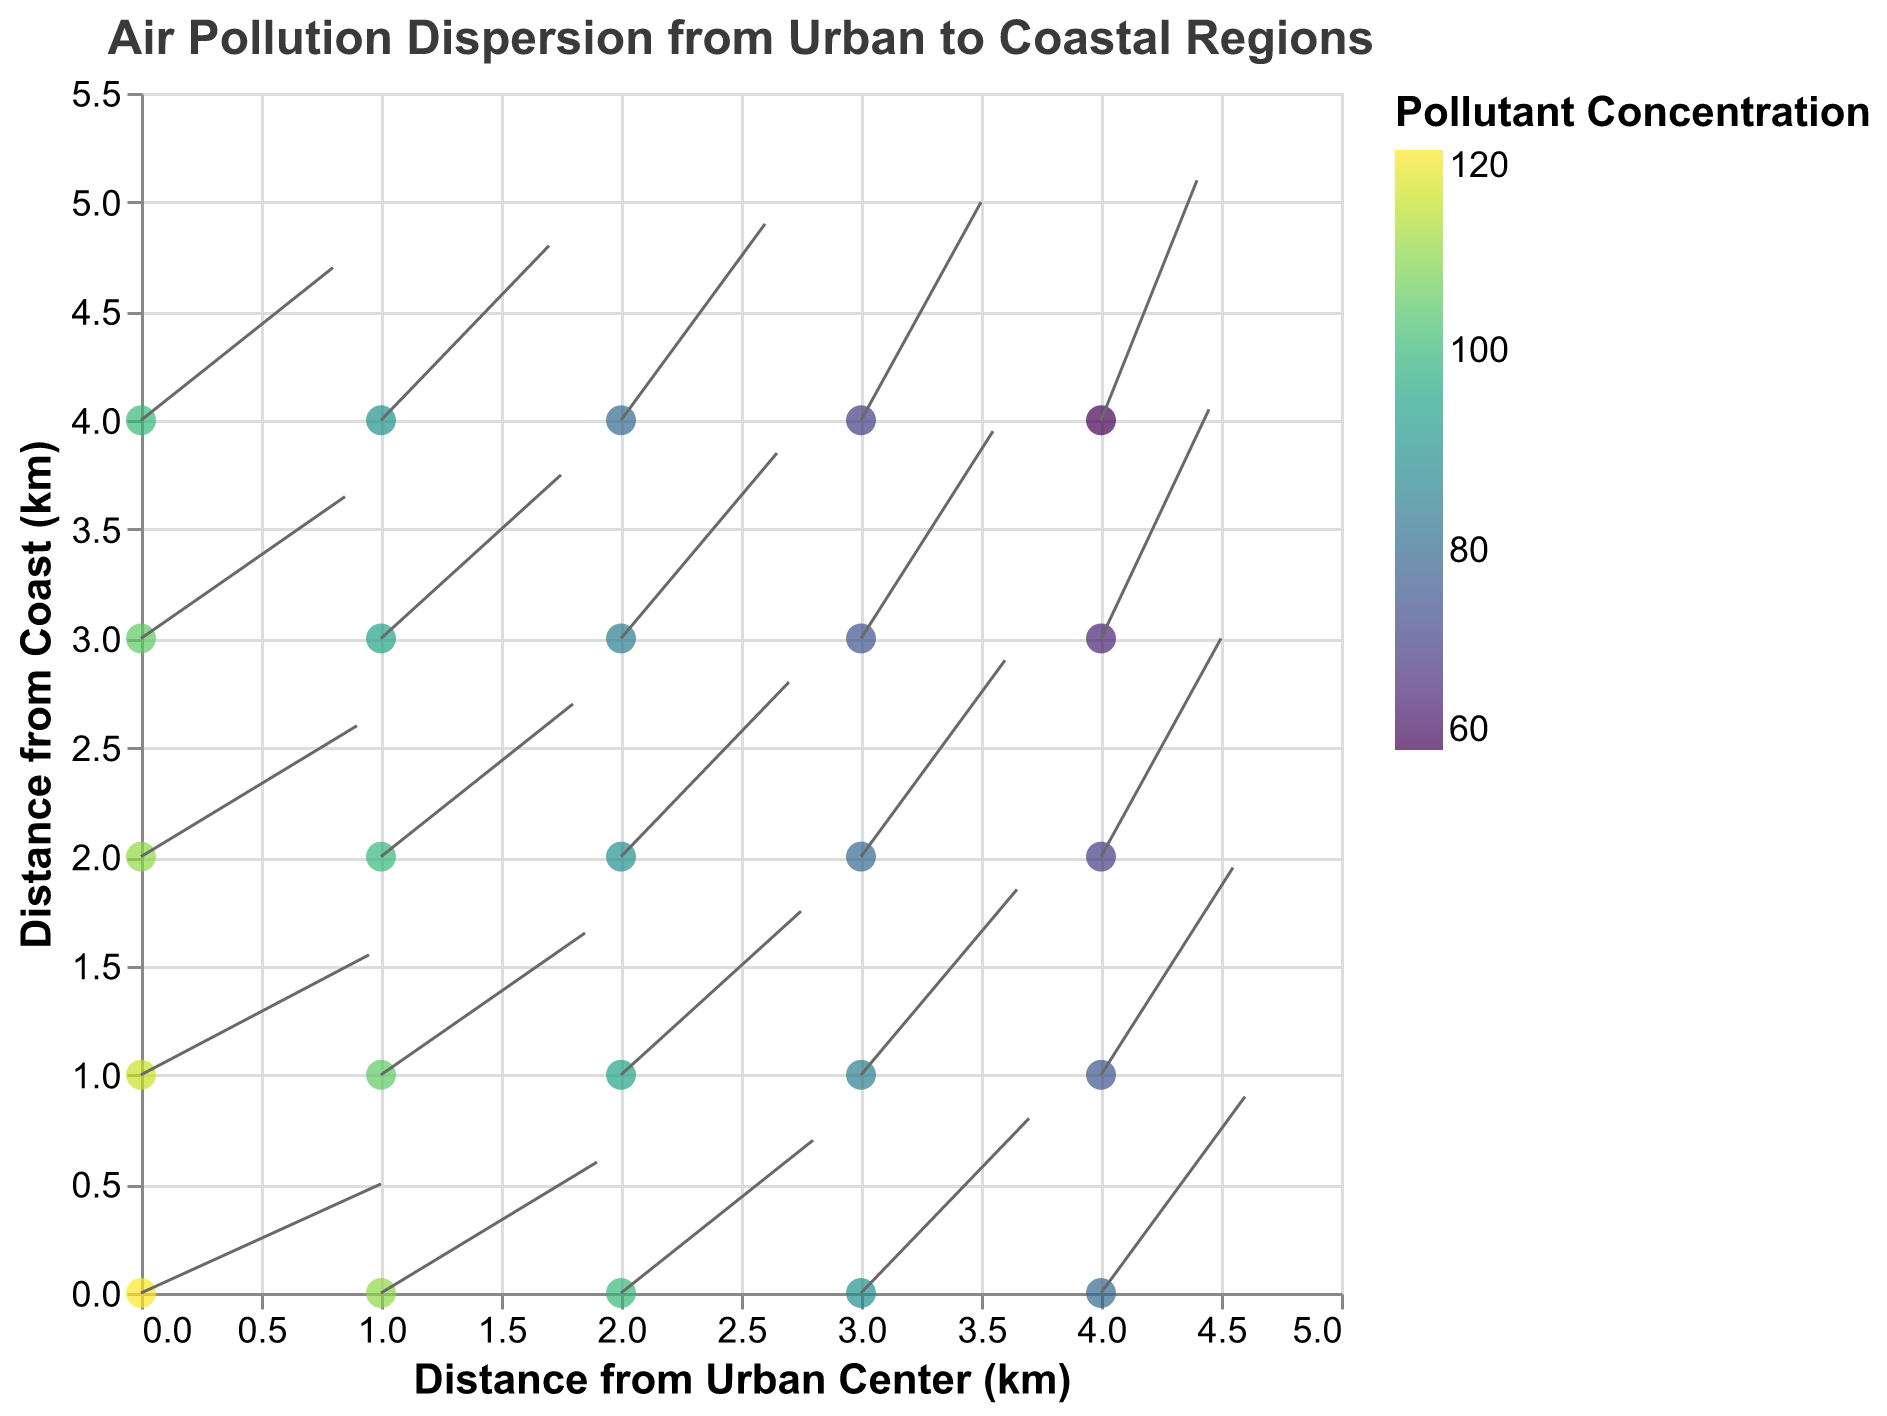What does the title of the plot say? The title of the plot is situated at the top and provides an overview of what the plot represents. It states "Air Pollution Dispersion from Urban to Coastal Regions".
Answer: "Air Pollution Dispersion from Urban to Coastal Regions" What's the highest pollutant concentration in the plot? By looking at the color coding of the points and the legend, the darkest color, which signifies the highest concentration, corresponds to the value 120.
Answer: 120 Which axis represents the distance from the urban center? The x-axis of the plot is labeled "Distance from Urban Center (km)", indicating that it represents the distance from the urban center.
Answer: x-axis What is the pollutant concentration at coordinates (2,2)? Locate the point at coordinates (2,2) and refer to its color based on the legend. The color indicates a pollutant concentration of 90.
Answer: 90 How does pollutant concentration change as you move from the urban center (x=0) to the coast (x=4) along y=0? By following the points from (0,0) to (4,0), the concentration decreases from 120 to 80, showing a reduction in pollutant concentration as one moves toward the coast along y=0.
Answer: Decreases from 120 to 80 What is the average pollutant concentration across all points at y=1? Sum the concentrations at y=1 (115, 105, 95, 85, 75) and divide by the number of points (5). (115+105+95+85+75)/5 = 475/5.
Answer: 95 Which point has the longest vector (u, v)? The vector magnitude is calculated using the formula √(u^2 + v^2). The point (4,4) has the highest magnitude, calculated as √(0.8^2 + 2.2^2) = √(0.64 + 4.84) = √5.48 ≈ 2.34.
Answer: (4,4) Compare the pollutant concentrations at (2,0) and (2,4). Which is higher? Refer to the concentration values at (2,0) and (2,4). The concentration at (2,0) is 100, while (2,4) has a concentration of 80. Thus, (2,0) has a higher concentration.
Answer: (2,0) By how much does the concentration decrease from (1,0) to (1,4) along the y-axis? Subtract the concentration at (1,4) from (1,0). The concentrations are 110 and 90, respectively. 110 - 90 = 20.
Answer: 20 In which direction do the vectors generally point? Observe the general trend of the vectors in the plot. They mostly point from the left to the right and slightly upward, indicating the movement of pollutants towards the coast and slightly upward.
Answer: Right and slightly upward 